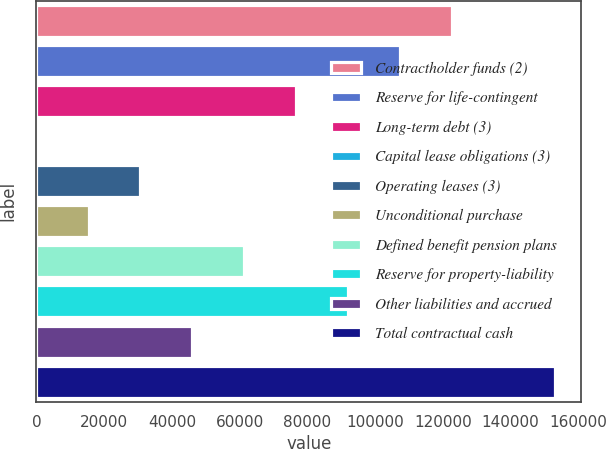Convert chart to OTSL. <chart><loc_0><loc_0><loc_500><loc_500><bar_chart><fcel>Contractholder funds (2)<fcel>Reserve for life-contingent<fcel>Long-term debt (3)<fcel>Capital lease obligations (3)<fcel>Operating leases (3)<fcel>Unconditional purchase<fcel>Defined benefit pension plans<fcel>Reserve for property-liability<fcel>Other liabilities and accrued<fcel>Total contractual cash<nl><fcel>122570<fcel>107256<fcel>76629.5<fcel>62<fcel>30689<fcel>15375.5<fcel>61316<fcel>91943<fcel>46002.5<fcel>153197<nl></chart> 